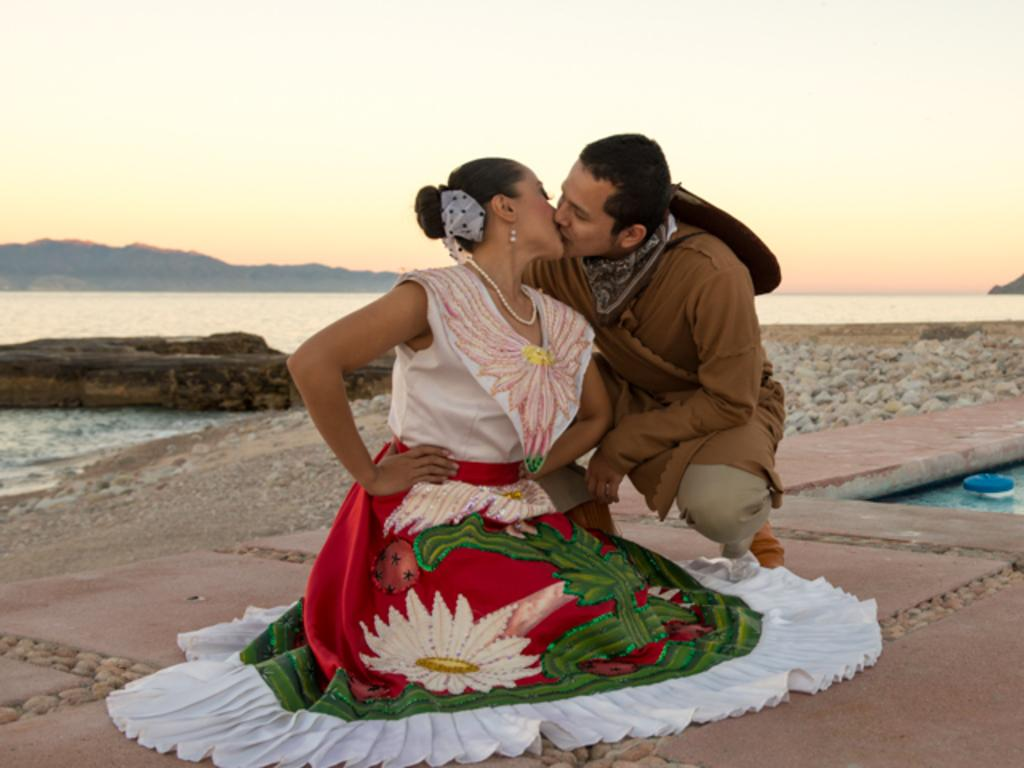What are the two people in the image doing? There is a man and a woman sitting on the ground in the image. What can be seen in the background of the image? There are stones, water, a hill, and the sky visible in the background of the image. What color is the pet's eye in the image? There is no pet present in the image, so it is not possible to answer that question. 